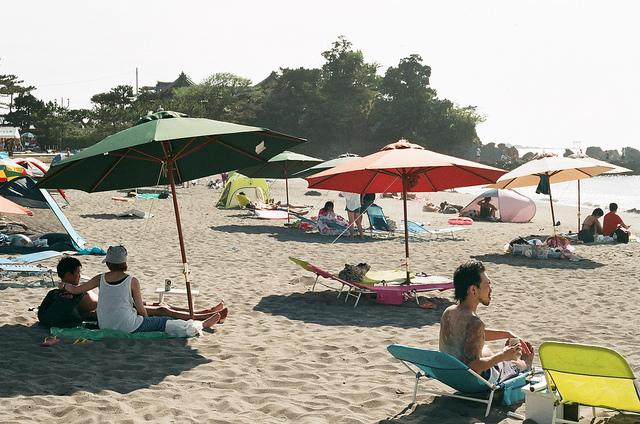How many sun umbrellas are there?
Write a very short answer. 5. Is this a beach?
Short answer required. Yes. How many umbrellas do you see?
Keep it brief. 5. What is in the beach?
Quick response, please. People. 